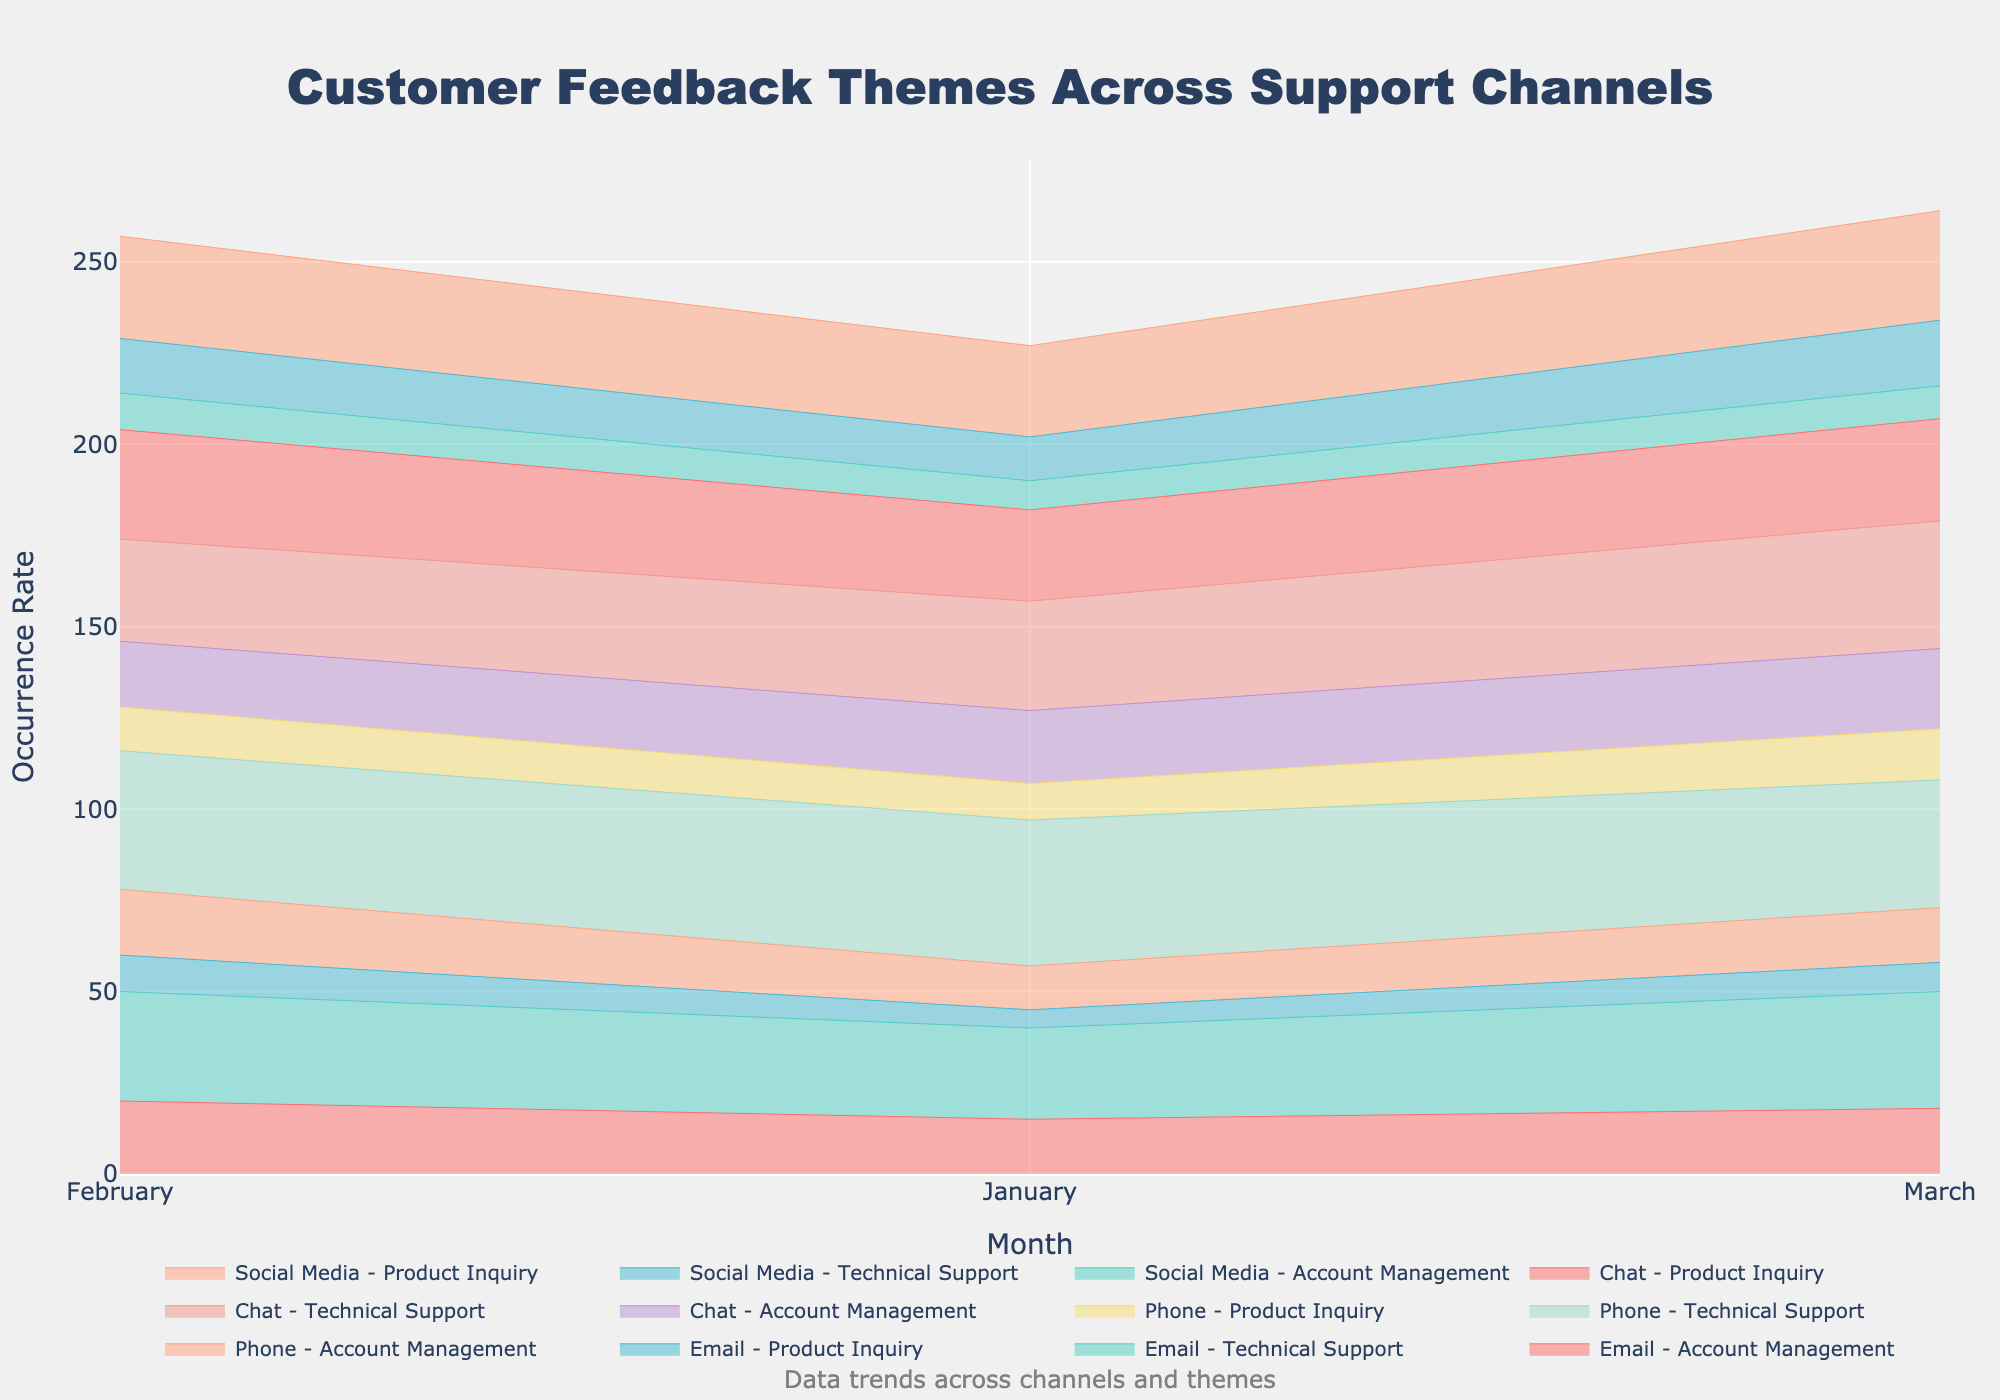What's the title of the figure? The title is usually located at the top-center of the figure and it summarizes the content of the plot.
Answer: Customer Feedback Themes Across Support Channels What are the months shown on the x-axis? The x-axis displays the months over which the data has been collected. By looking at the ticks on the x-axis, we can see the time periods covered.
Answer: January, February, March Which support channel had the highest occurrence rate for Technical Support in March? To find the highest occurrence rate for Technical Support in March, we look at the March data for each support channel and identify the channel with the highest rate.
Answer: Email How does the occurrence rate of Account Management change from January to March for the Phone channel? We observe the data points corresponding to the Phone channel for January, February, and March and note the changes in the occurrence rate of Account Management over these months.
Answer: It increases from 12 in January to 15 in March Which feedback theme shows an increasing trend across all months and channels? By observing each theme's trend line over the months across all channels, we look for a theme that consistently increases.
Answer: Product Inquiry Are there more occurrences of Technical Support issues via Email or Phone in February? We compare the occurrence rates for Technical Support issues via Email and Phone in February as shown by the height of the respective stacks.
Answer: Phone What is the total occurrence rate of Product Inquiry in March across all channels? We sum the occurrence rates of Product Inquiry for March across all channels (Email, Phone, Chat, Social Media).
Answer: 80 Is there any support channel where Account Management issues consistently decrease from January to March? We look at the trend line for Account Management across January, February, and March for each channel to see if it's consistently decreasing.
Answer: Social Media Which support channel had the most variation in Technical Support occurrence rates over the three months? To determine the most variation, we observe the difference between the highest and lowest occurrence rates for Technical Support in each channel over the three months.
Answer: Phone In which month does Chat have the highest overall occurrence rate for all themes combined? By summing the occurrence rates of all themes for the Chat channel in each month, we identify the month with the highest combined rate.
Answer: January 